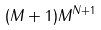Convert formula to latex. <formula><loc_0><loc_0><loc_500><loc_500>( M + 1 ) M ^ { N + 1 }</formula> 